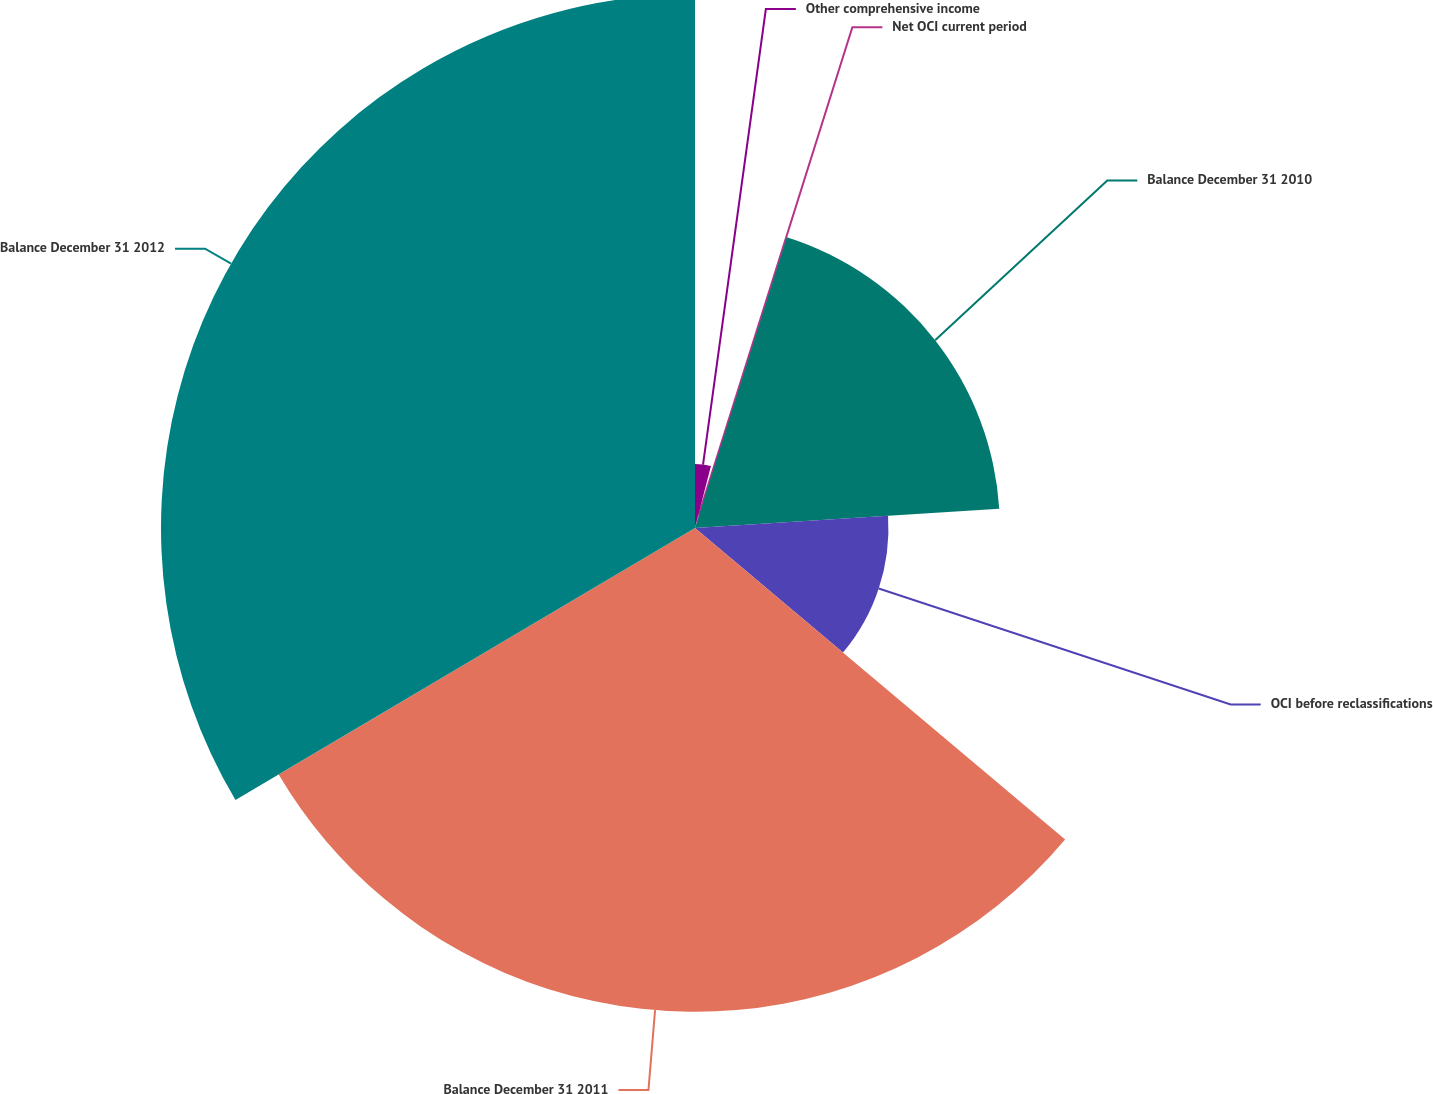<chart> <loc_0><loc_0><loc_500><loc_500><pie_chart><fcel>Other comprehensive income<fcel>Net OCI current period<fcel>Balance December 31 2010<fcel>OCI before reclassifications<fcel>Balance December 31 2011<fcel>Balance December 31 2012<nl><fcel>4.01%<fcel>0.86%<fcel>19.13%<fcel>12.14%<fcel>30.36%<fcel>33.51%<nl></chart> 